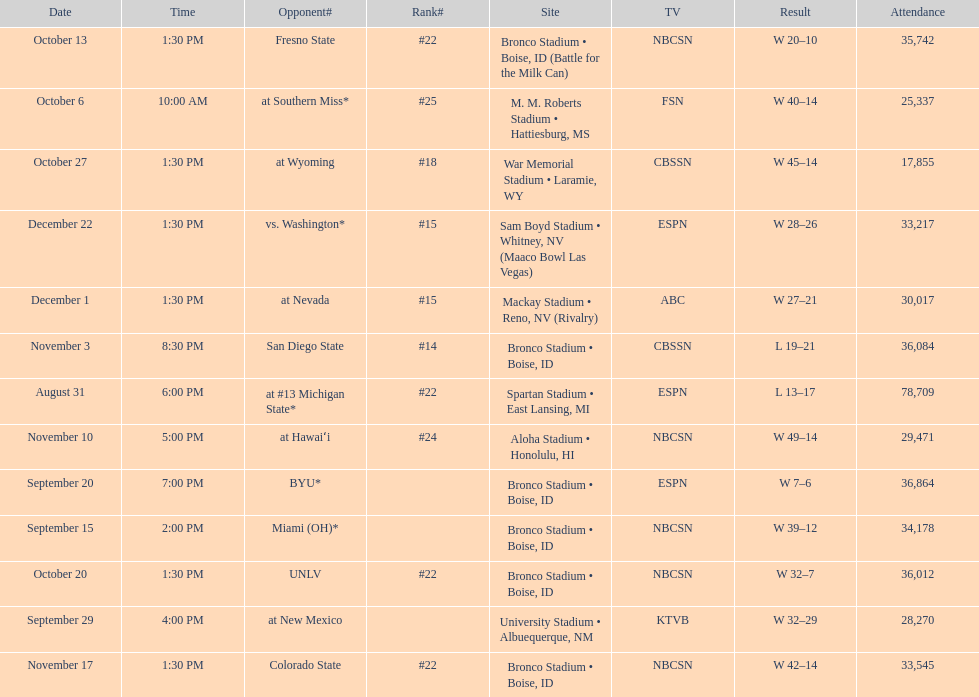Which team has the highest rank among those listed? San Diego State. 